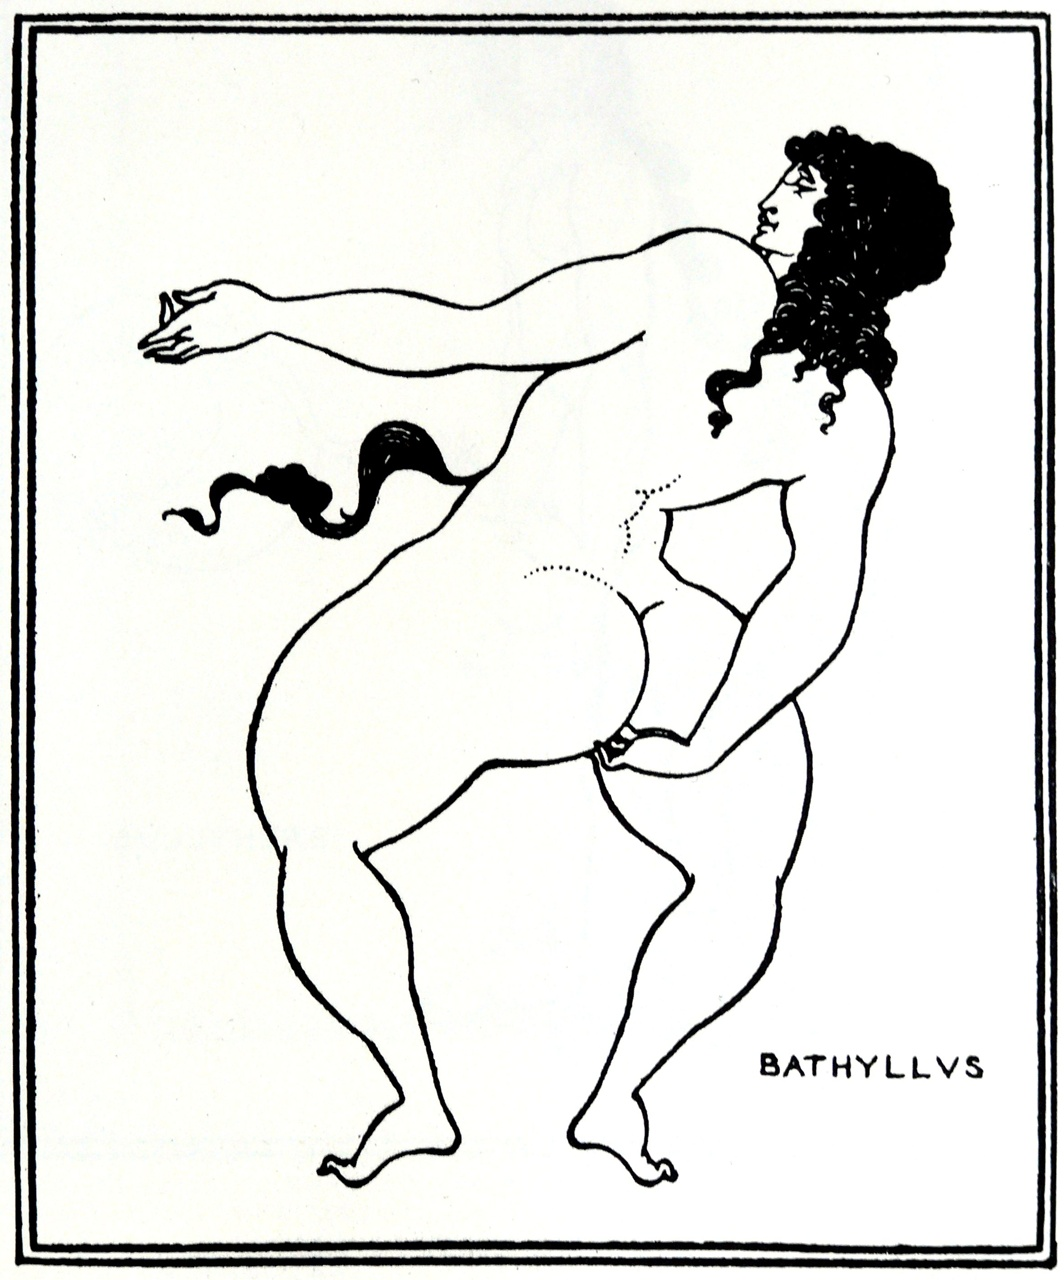What might the object in the figure's right hand signify? The object, appearing small and possibly ritualistic, could signify various elements depending on the historical or mythical narrative it is associated with. In the context of Greek art, it could represent a tool or symbolic item used in athletic, theatrical, or religious activities, reflecting the individual's role or the storyline portrayed. 